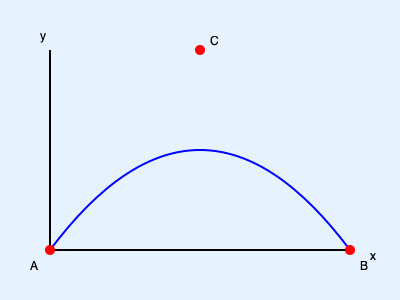Analyzing the trajectory of a dive from a starting block, the path can be approximated by a parabola. If the horizontal distance between the starting block (A) and the entry point (B) is 3 meters, and the maximum height of the dive (C) is 1.5 meters, what is the equation of the parabola representing the diver's trajectory? Assume the origin (0,0) is at point A. Let's approach this step-by-step:

1) The general equation of a parabola is $y = ax^2 + bx + c$, where $a$, $b$, and $c$ are constants.

2) We know three points on this parabola:
   A(0, 0) - the starting point
   B(3, 0) - the entry point
   C(1.5, 1.5) - the highest point (assuming it's halfway between A and B)

3) Since A is at (0, 0), we know that $c = 0$. Our equation is now $y = ax^2 + bx$.

4) Let's use point B: When $x = 3$, $y = 0$
   $0 = a(3)^2 + b(3)$
   $0 = 9a + 3b$ ... (Equation 1)

5) Now let's use point C: When $x = 1.5$, $y = 1.5$
   $1.5 = a(1.5)^2 + b(1.5)$
   $1.5 = 2.25a + 1.5b$ ... (Equation 2)

6) From Equation 1: $b = -3a$

7) Substitute this into Equation 2:
   $1.5 = 2.25a + 1.5(-3a)$
   $1.5 = 2.25a - 4.5a$
   $1.5 = -2.25a$
   $a = -\frac{2}{3}$

8) Now we can find $b$:
   $b = -3(-\frac{2}{3}) = 2$

9) Therefore, the equation of the parabola is:
   $y = -\frac{2}{3}x^2 + 2x$
Answer: $y = -\frac{2}{3}x^2 + 2x$ 